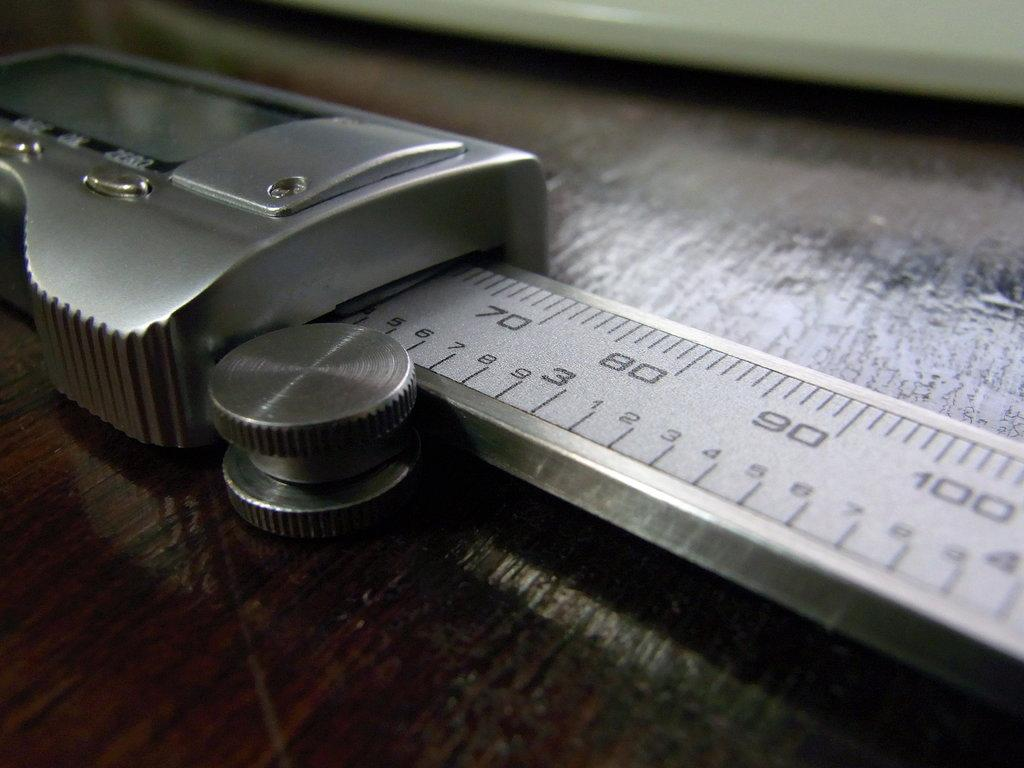<image>
Relay a brief, clear account of the picture shown. A silver measuring device goes up to at least 100 units. 